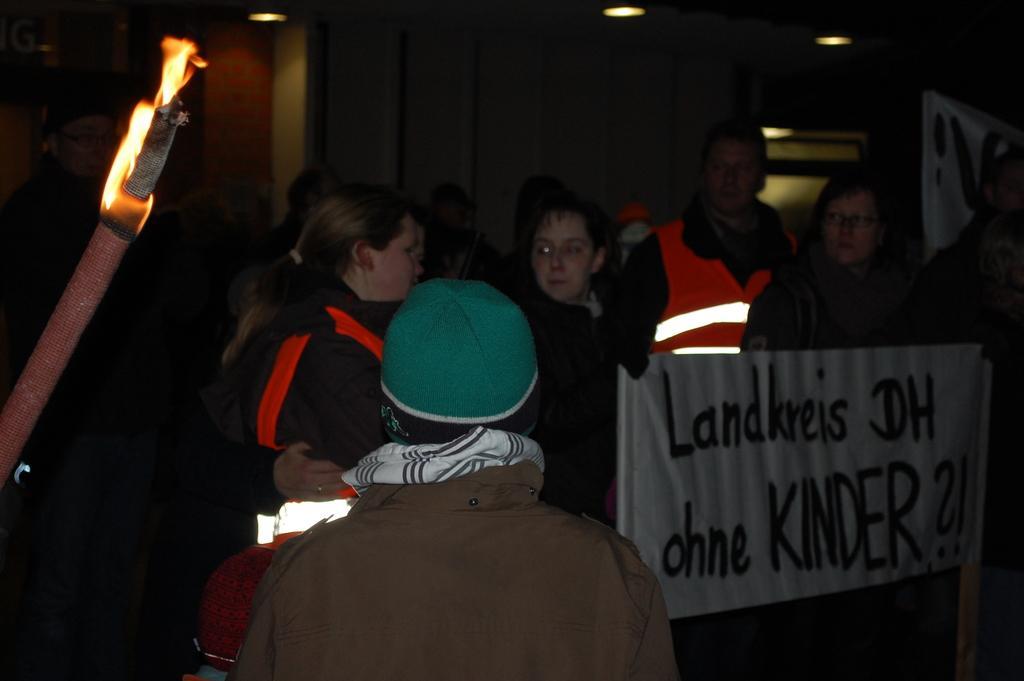Describe this image in one or two sentences. In this picture I can see people who are standing in front and I see a banner in front on which there is something written and on the left side of this image I see the fire. In the background I see the lights on the top of this image. 